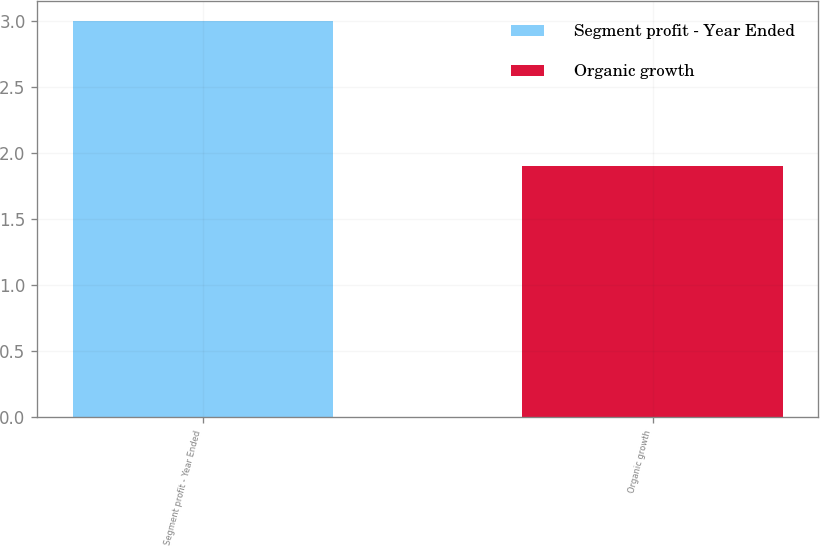Convert chart. <chart><loc_0><loc_0><loc_500><loc_500><bar_chart><fcel>Segment profit - Year Ended<fcel>Organic growth<nl><fcel>3<fcel>1.9<nl></chart> 